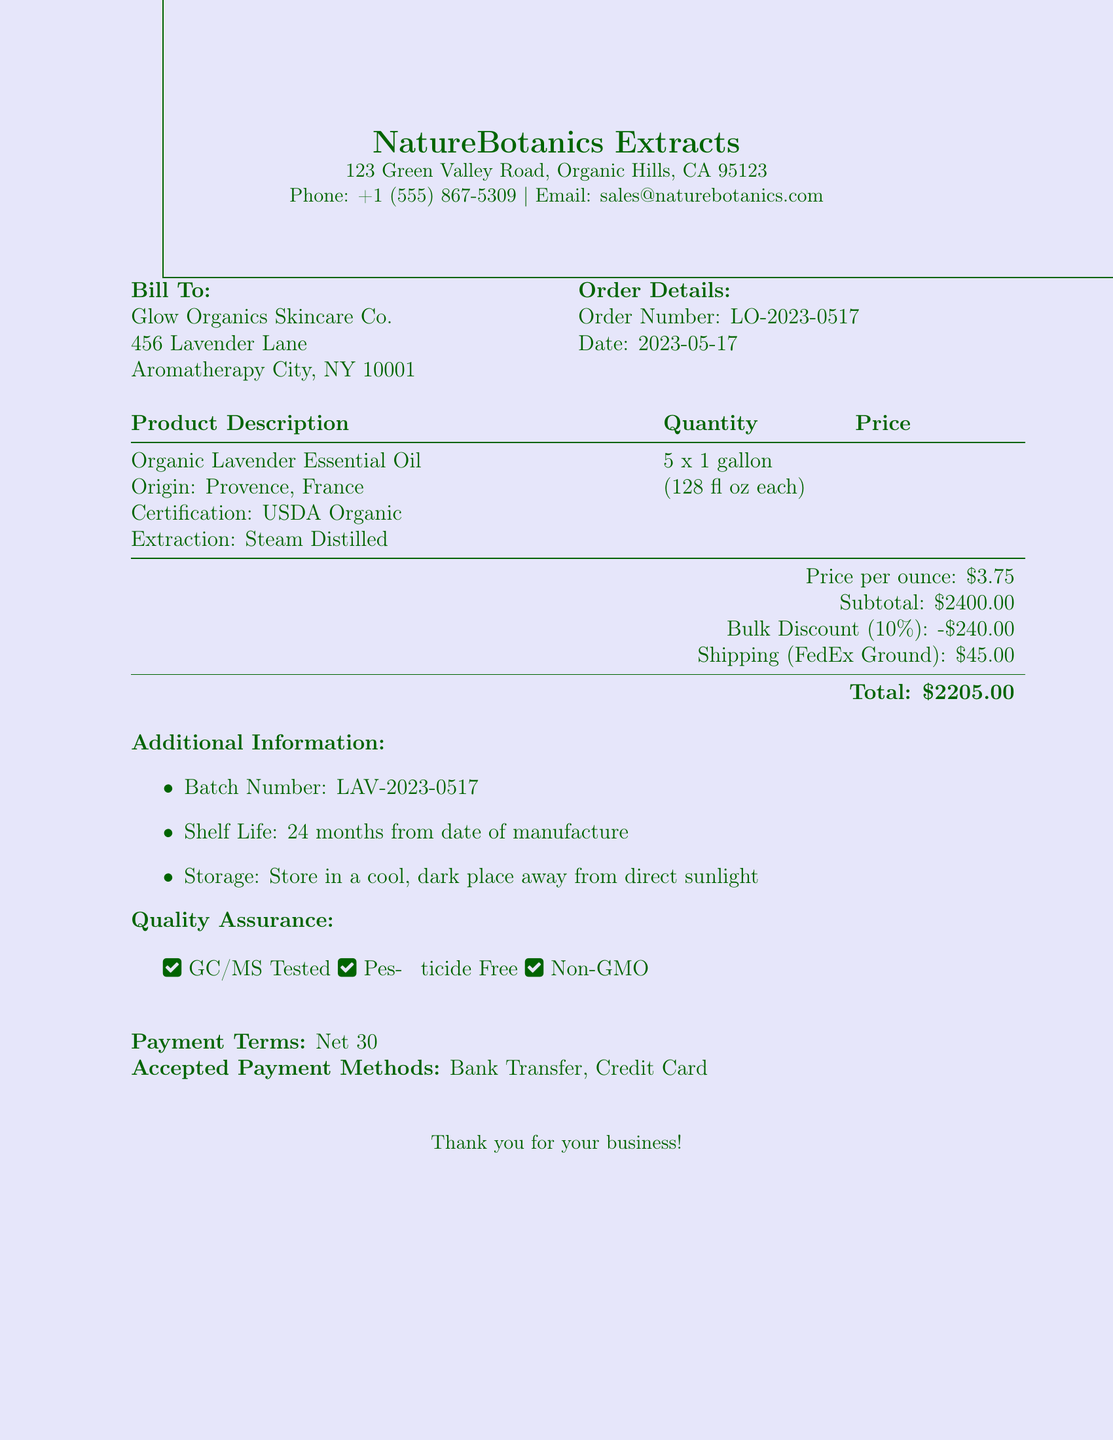What is the company name? The company name is listed at the top of the document as the supplier of the product.
Answer: NatureBotanics Extracts What is the order number? The order number is mentioned in the order details section of the document.
Answer: LO-2023-0517 What is the price per ounce? The price per ounce is clearly stated in the pricing section of the document.
Answer: $3.75 How many units were ordered? The quantity section of the document specifies the number of units ordered.
Answer: 5 What is the total price after discount? The total price after discount is indicated in the pricing section.
Answer: $2160.00 What is the origin of the lavender essential oil? The origin of the product is mentioned in the product description section.
Answer: Provence, France What is the bulk discount percentage? The document specifies the bulk discount in the pricing section.
Answer: 10% What is the shipping cost? The shipping cost is detailed in the shipping section of the document.
Answer: $45.00 How long is the shelf life of the product? The shelf life information is found in the additional information section.
Answer: 24 months from date of manufacture 